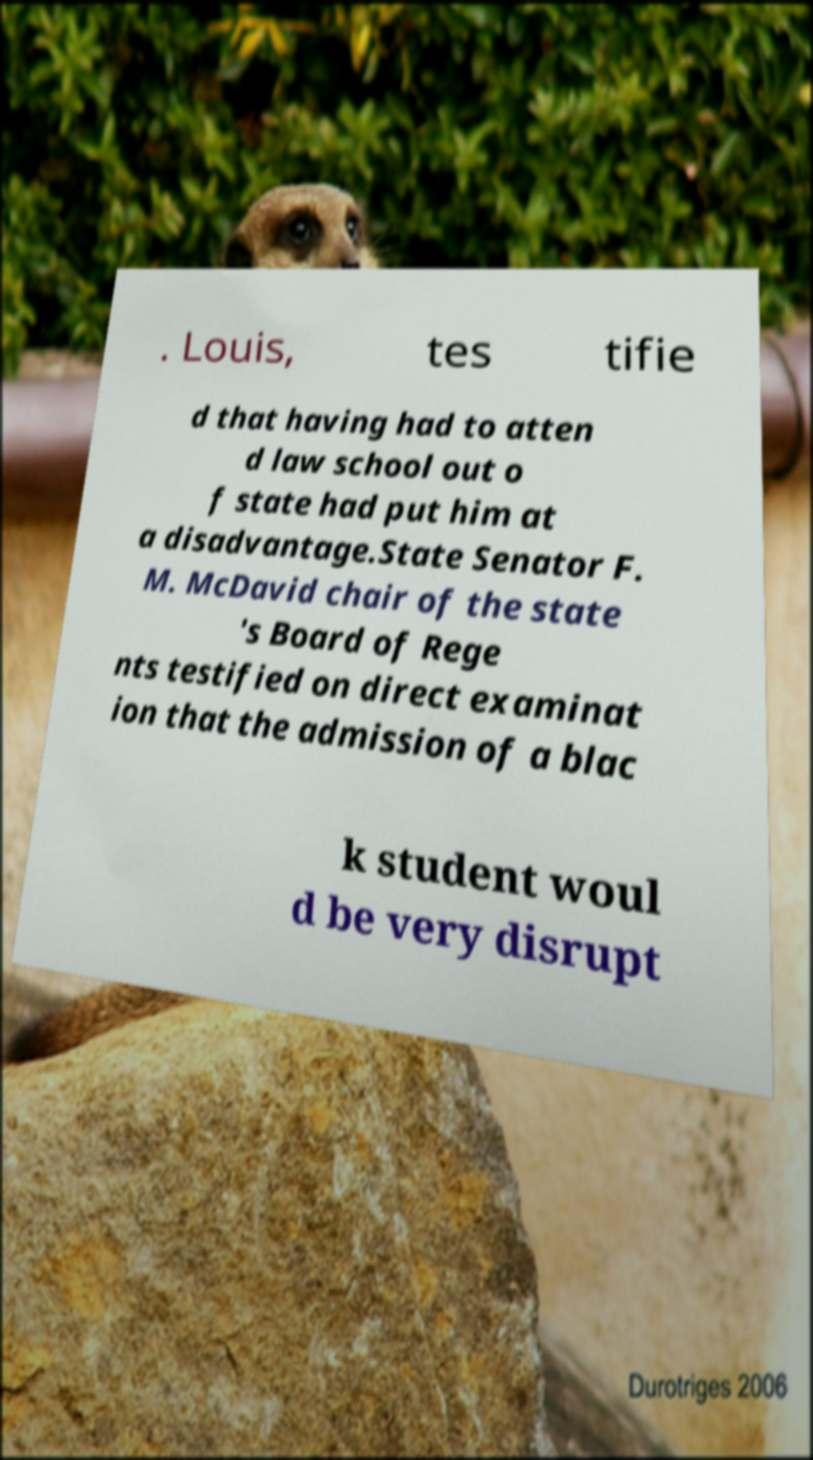I need the written content from this picture converted into text. Can you do that? . Louis, tes tifie d that having had to atten d law school out o f state had put him at a disadvantage.State Senator F. M. McDavid chair of the state 's Board of Rege nts testified on direct examinat ion that the admission of a blac k student woul d be very disrupt 